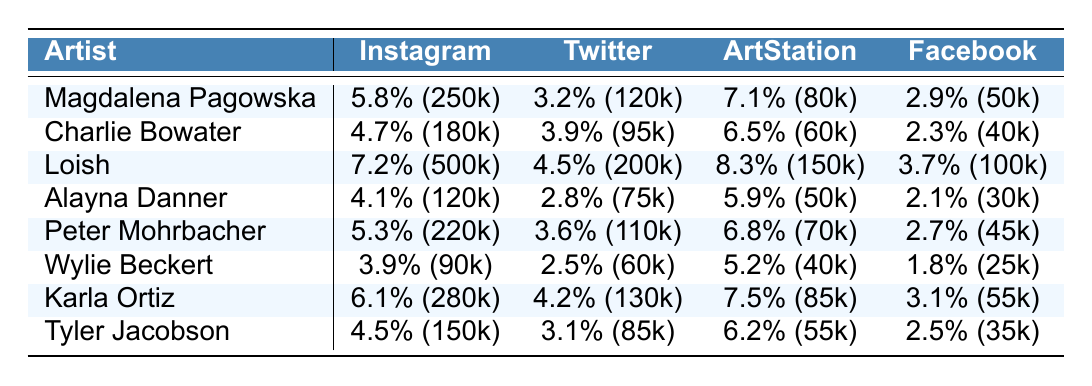What is the engagement rate for Loish on ArtStation? The table shows that Loish has an engagement rate of 8.3% on ArtStation.
Answer: 8.3% Which artist has the highest engagement rate on Instagram? According to the table, Loish has the highest engagement rate on Instagram at 7.2%.
Answer: Loish What is the average engagement rate across all platforms for Alayna Danner? To find Alayna Danner's average engagement rate, add her engagement rates: 4.1% + 2.8% + 5.9% + 2.1% = 14.9%. Then, divide by 4 (number of platforms): 14.9% / 4 = 3.725%.
Answer: 3.725% Which artist has the lowest overall engagement rate? We must compare the engagement rates for each artist across all platforms. Summing up the engagement rates: 5.8 + 3.2 + 7.1 + 2.9 = 19.0 for Magdalena Pagowska, 4.7 + 3.9 + 6.5 + 2.3 = 17.4 for Charlie Bowater, and so on. The artist with the lowest sum is Wylie Beckert with 3.9 + 2.5 + 5.2 + 1.8 = 13.4.
Answer: Wylie Beckert What is the difference in the engagement rate on Facebook between Karla Ortiz and Tyler Jacobson? Karla Ortiz has an engagement rate of 3.1% on Facebook while Tyler Jacobson has 2.5%. The difference is calculated as 3.1% - 2.5% = 0.6%.
Answer: 0.6% Is the engagement rate for artists generally higher on Instagram compared to Facebook? By examining the engagement rates across the table, we see that most artists have higher rates on Instagram compared to Facebook, confirming that it is generally true.
Answer: Yes How does the average post frequency of Peter Mohrbacher compare to that of Loish? For Peter Mohrbacher, the average post frequency is 2.3, and for Loish, it is 3.0. The comparison shows Loish posts more frequently: 3.0 - 2.3 = 0.7 more posts on average.
Answer: Loish posts more frequently by 0.7 posts Which platform has the highest average engagement rate across all artists? To determine the average engagement rate per platform, we need to calculate the average for each. For example, on Instagram: (5.8 + 4.7 + 7.2 + 4.1 + 5.3 + 3.9 + 6.1 + 4.5) / 8 = 5.4%. By calculating similarly for the others, ArtStation has the highest average of 6.7%.
Answer: ArtStation What artist has the highest follower count on Twitter? Looking at the follower counts on Twitter, Loish has 200,000 followers, which is higher than all the other artists listed.
Answer: Loish Does Magdalena Pagowska have a higher engagement rate on Facebook than Peter Mohrbacher? Magdalena Pagowska's engagement rate on Facebook is 2.9% while Peter Mohrbacher's is 2.7%. Since 2.9% is greater than 2.7%, the statement is true.
Answer: Yes 